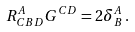<formula> <loc_0><loc_0><loc_500><loc_500>R ^ { A } _ { C B D } G ^ { C D } = 2 \delta ^ { A } _ { B } \, .</formula> 